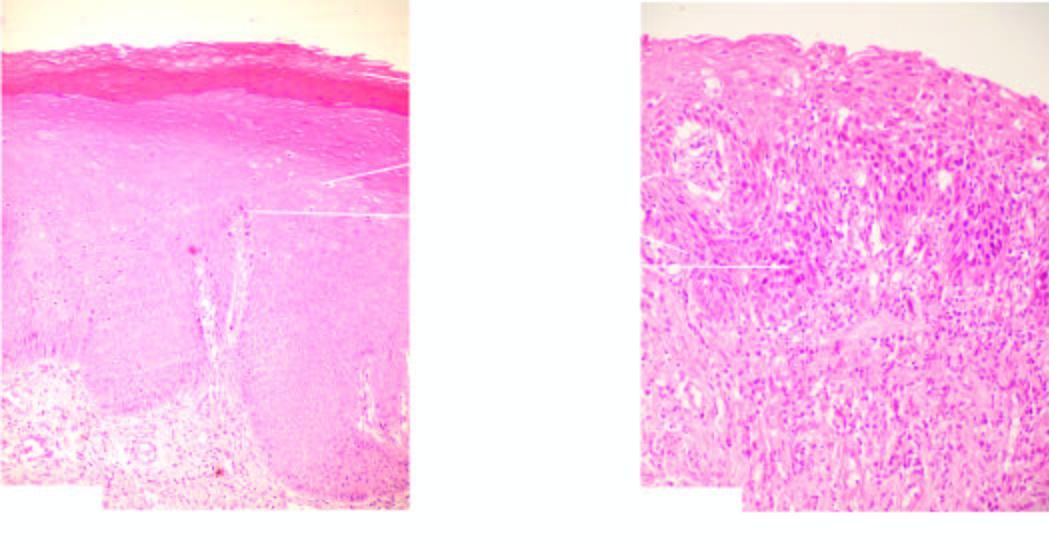s the number of layers increased?
Answer the question using a single word or phrase. Yes 